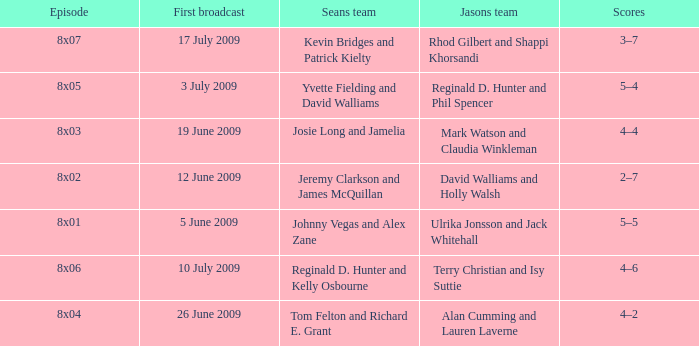What is the broadcast date where Jason's team is Rhod Gilbert and Shappi Khorsandi? 17 July 2009. 